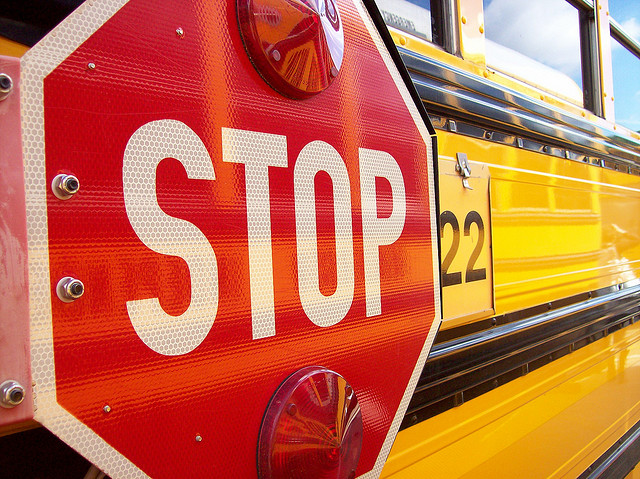<image>What is in the reflection of the stop sign? There may be no reflection in the stop sign. But if there is, it could be a bus or school bus. What is in the reflection of the stop sign? I don't know what is in the reflection of the stop sign. It can be seen a bus or another bus. 